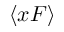Convert formula to latex. <formula><loc_0><loc_0><loc_500><loc_500>\langle x F \rangle</formula> 